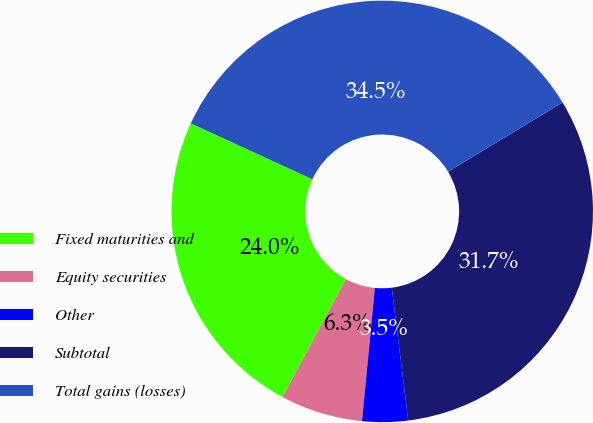<chart> <loc_0><loc_0><loc_500><loc_500><pie_chart><fcel>Fixed maturities and<fcel>Equity securities<fcel>Other<fcel>Subtotal<fcel>Total gains (losses)<nl><fcel>24.01%<fcel>6.32%<fcel>3.5%<fcel>31.68%<fcel>34.49%<nl></chart> 